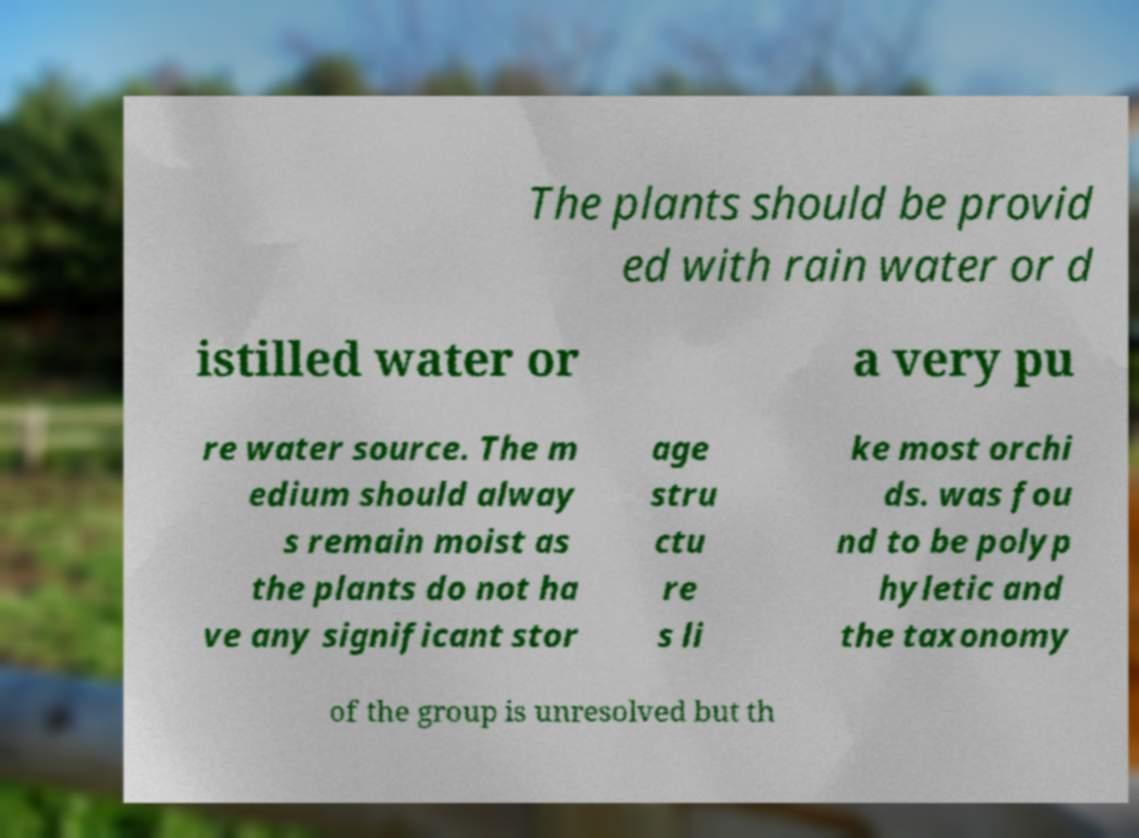For documentation purposes, I need the text within this image transcribed. Could you provide that? The plants should be provid ed with rain water or d istilled water or a very pu re water source. The m edium should alway s remain moist as the plants do not ha ve any significant stor age stru ctu re s li ke most orchi ds. was fou nd to be polyp hyletic and the taxonomy of the group is unresolved but th 